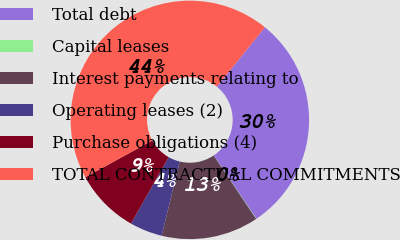Convert chart to OTSL. <chart><loc_0><loc_0><loc_500><loc_500><pie_chart><fcel>Total debt<fcel>Capital leases<fcel>Interest payments relating to<fcel>Operating leases (2)<fcel>Purchase obligations (4)<fcel>TOTAL CONTRACTUAL COMMITMENTS<nl><fcel>29.73%<fcel>0.05%<fcel>13.18%<fcel>4.42%<fcel>8.8%<fcel>43.82%<nl></chart> 